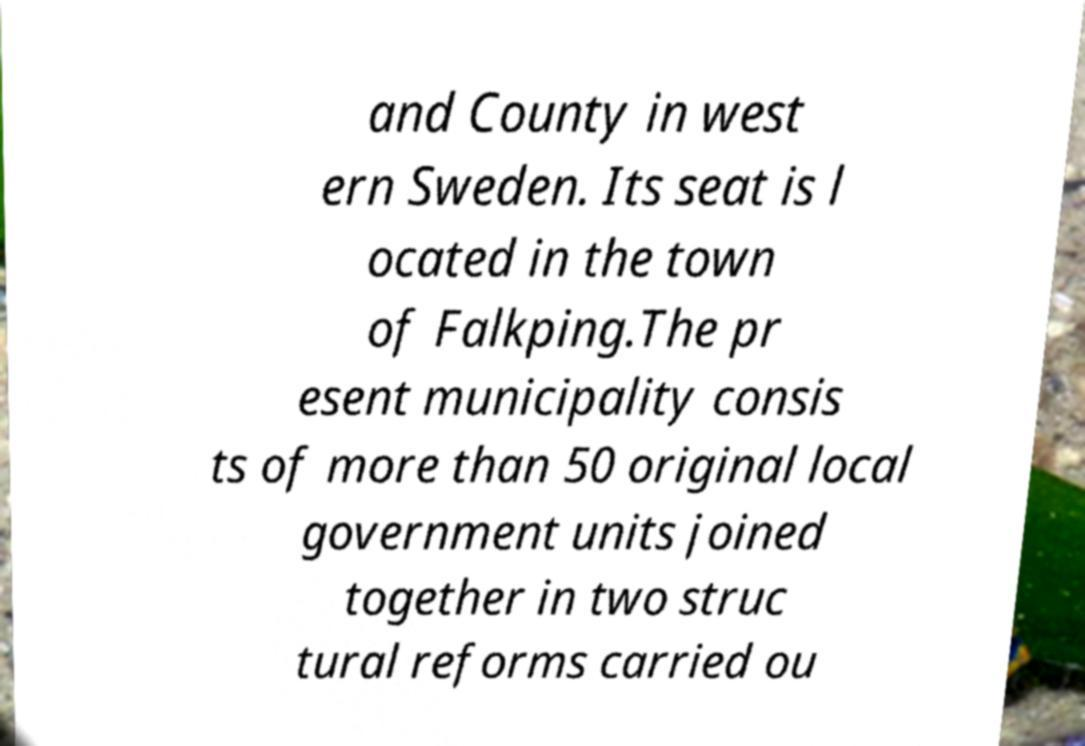For documentation purposes, I need the text within this image transcribed. Could you provide that? and County in west ern Sweden. Its seat is l ocated in the town of Falkping.The pr esent municipality consis ts of more than 50 original local government units joined together in two struc tural reforms carried ou 